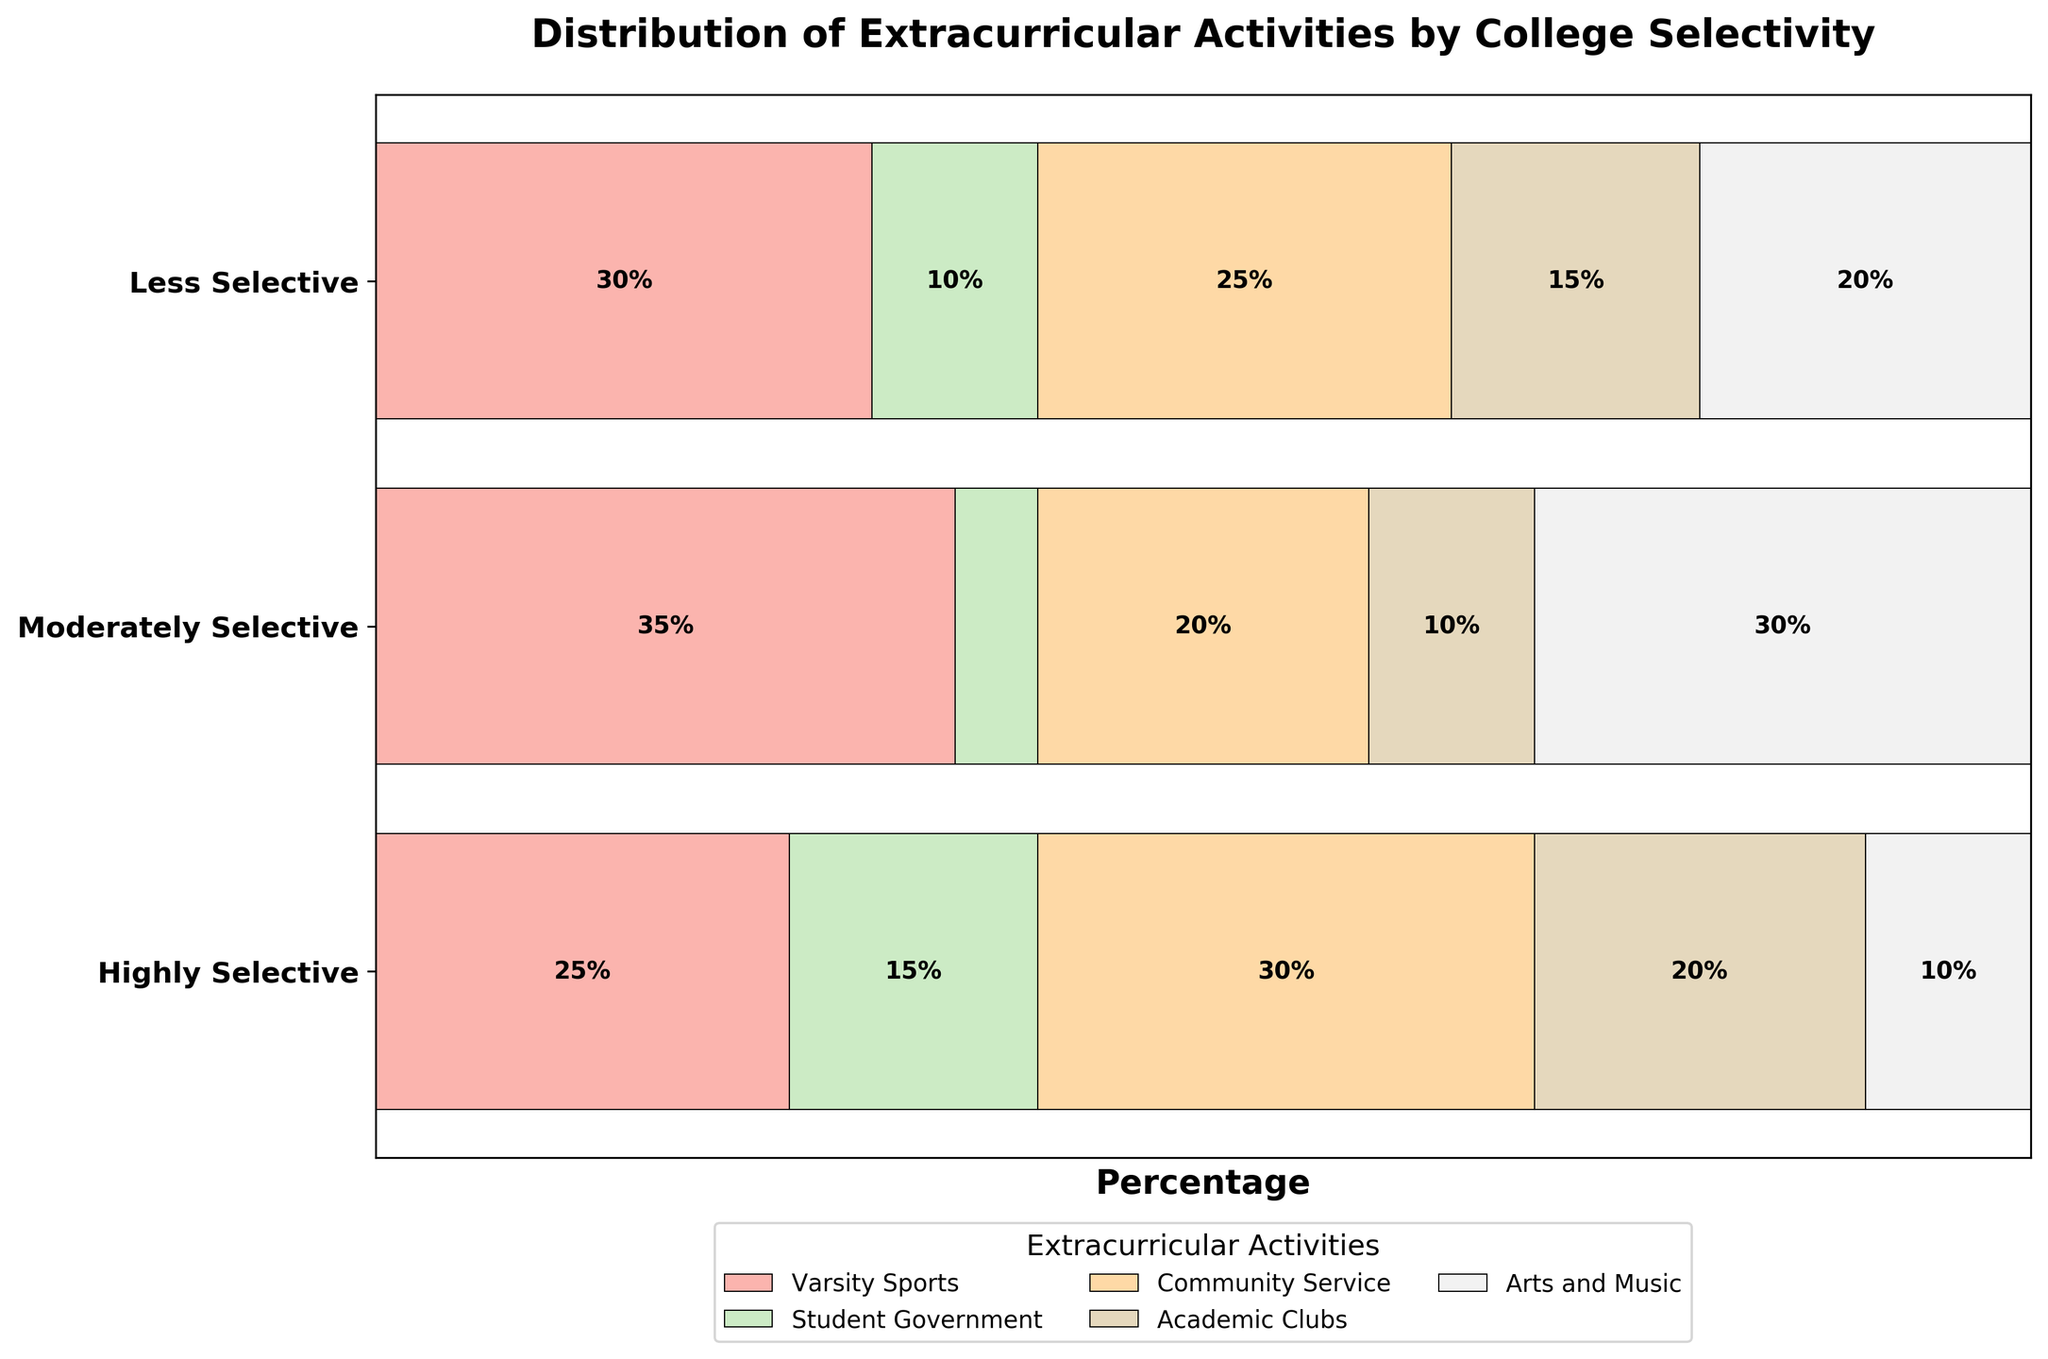What is the title of the plot? The title is usually displayed at the top of the plot and describes what the plot represents. Here, the title "Distribution of Extracurricular Activities by College Selectivity" indicates the content of the plot.
Answer: Distribution of Extracurricular Activities by College Selectivity Which extracurricular activity has the highest percentage in highly selective colleges? To determine this, look at the segments corresponding to highly selective colleges. Among these, the largest segment is for Community Service, at 30%.
Answer: Community Service How do the percentages of students involved in Varsity Sports compare across college selectivity levels? Compare the segments labeled Varsity Sports for each college selectivity level. Highly Selective is at 25%, Moderately Selective at 30%, and Less Selective at 35%.
Answer: Less Selective > Moderately Selective > Highly Selective Which college selectivity level has the highest percentage of students involved in Arts and Music? Find the segments labeled Arts and Music and compare their sizes. The largest is for Less Selective colleges, at 30%.
Answer: Less Selective What is the total percentage of students involved in Academic Clubs across all selectivity levels? Add the percentages for Academic Clubs across all selectivity levels: 20% (Highly Selective) + 15% (Moderately Selective) + 10% (Less Selective) = 45%.
Answer: 45% In moderately selective colleges, which extracurricular activity has the lowest percentage of students? Look at the segments for Moderately Selective colleges. The smallest segment is for Student Government, at 10%.
Answer: Student Government How much more popular is Community Service compared to Student Government in highly selective colleges? Subtract the percentage of Student Government from the percentage of Community Service in Highly Selective colleges: 30% - 15% = 15%.
Answer: 15% Which extracurricular activity shows the most significant variation in percentages across different college selectivity levels? Compare the ranges for each activity across selectivity levels. Student Government varies from 5% to 15%, but Varsity Sports ranges from 25% to 35%, which is a bigger variation.
Answer: Varsity Sports Between highly and moderately selective colleges, what is the difference in the percentage of students involved in Academic Clubs? Subtract the percentage of Academic Clubs in Moderately Selective from Highly Selective colleges: 20% - 15% = 5%.
Answer: 5% For less selective colleges, what proportion of students are involved in either Varsity Sports or Arts and Music? Add the percentages for Varsity Sports and Arts and Music in Less Selective colleges: 35% + 30% = 65%.
Answer: 65% 